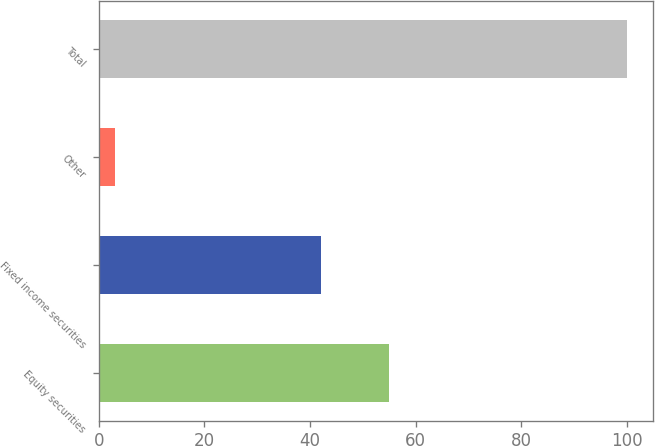Convert chart to OTSL. <chart><loc_0><loc_0><loc_500><loc_500><bar_chart><fcel>Equity securities<fcel>Fixed income securities<fcel>Other<fcel>Total<nl><fcel>55<fcel>42<fcel>3<fcel>100<nl></chart> 